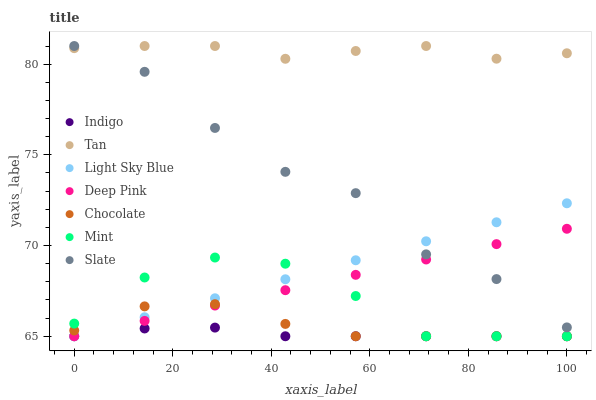Does Indigo have the minimum area under the curve?
Answer yes or no. Yes. Does Tan have the maximum area under the curve?
Answer yes or no. Yes. Does Slate have the minimum area under the curve?
Answer yes or no. No. Does Slate have the maximum area under the curve?
Answer yes or no. No. Is Deep Pink the smoothest?
Answer yes or no. Yes. Is Slate the roughest?
Answer yes or no. Yes. Is Indigo the smoothest?
Answer yes or no. No. Is Indigo the roughest?
Answer yes or no. No. Does Deep Pink have the lowest value?
Answer yes or no. Yes. Does Slate have the lowest value?
Answer yes or no. No. Does Tan have the highest value?
Answer yes or no. Yes. Does Indigo have the highest value?
Answer yes or no. No. Is Deep Pink less than Tan?
Answer yes or no. Yes. Is Tan greater than Deep Pink?
Answer yes or no. Yes. Does Chocolate intersect Indigo?
Answer yes or no. Yes. Is Chocolate less than Indigo?
Answer yes or no. No. Is Chocolate greater than Indigo?
Answer yes or no. No. Does Deep Pink intersect Tan?
Answer yes or no. No. 